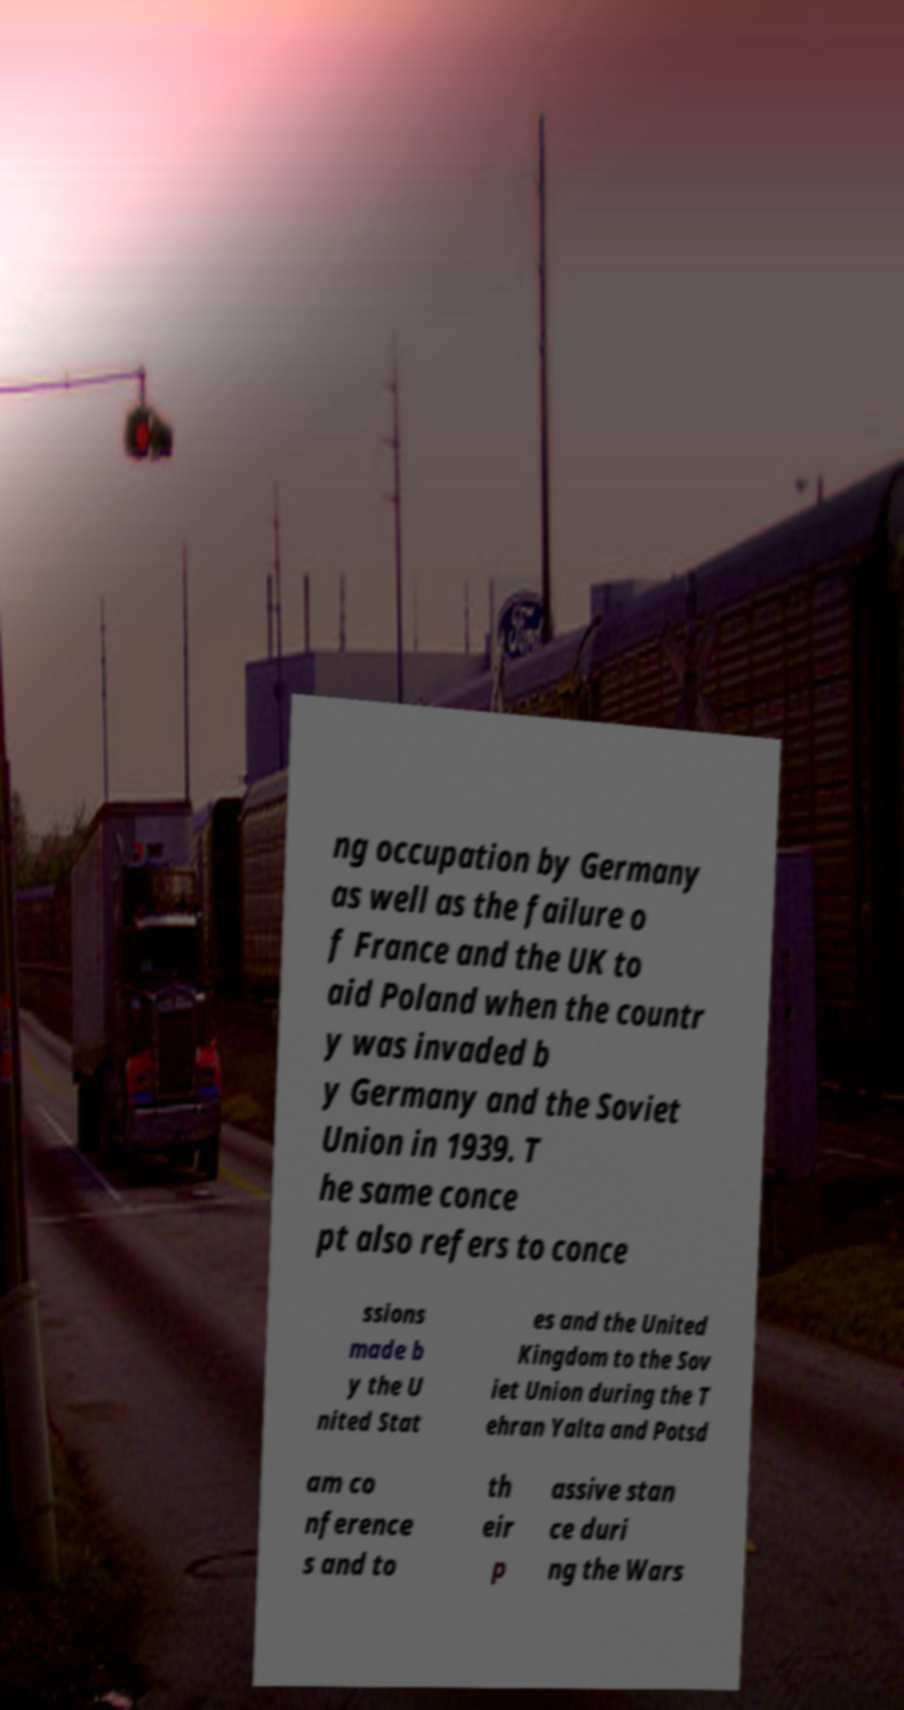Could you assist in decoding the text presented in this image and type it out clearly? ng occupation by Germany as well as the failure o f France and the UK to aid Poland when the countr y was invaded b y Germany and the Soviet Union in 1939. T he same conce pt also refers to conce ssions made b y the U nited Stat es and the United Kingdom to the Sov iet Union during the T ehran Yalta and Potsd am co nference s and to th eir p assive stan ce duri ng the Wars 